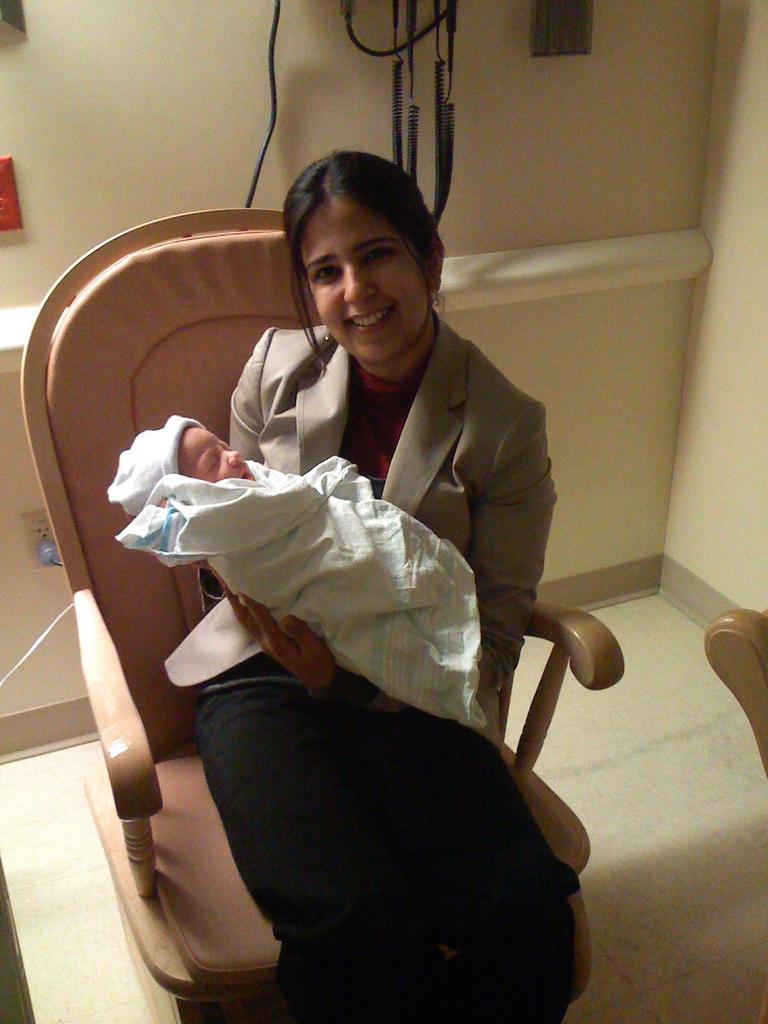How would you summarize this image in a sentence or two? In this image I can see a woman is sitting on a chair and holding a baby. I can also see a smile on her face. I can see she is wearing a blazer. 